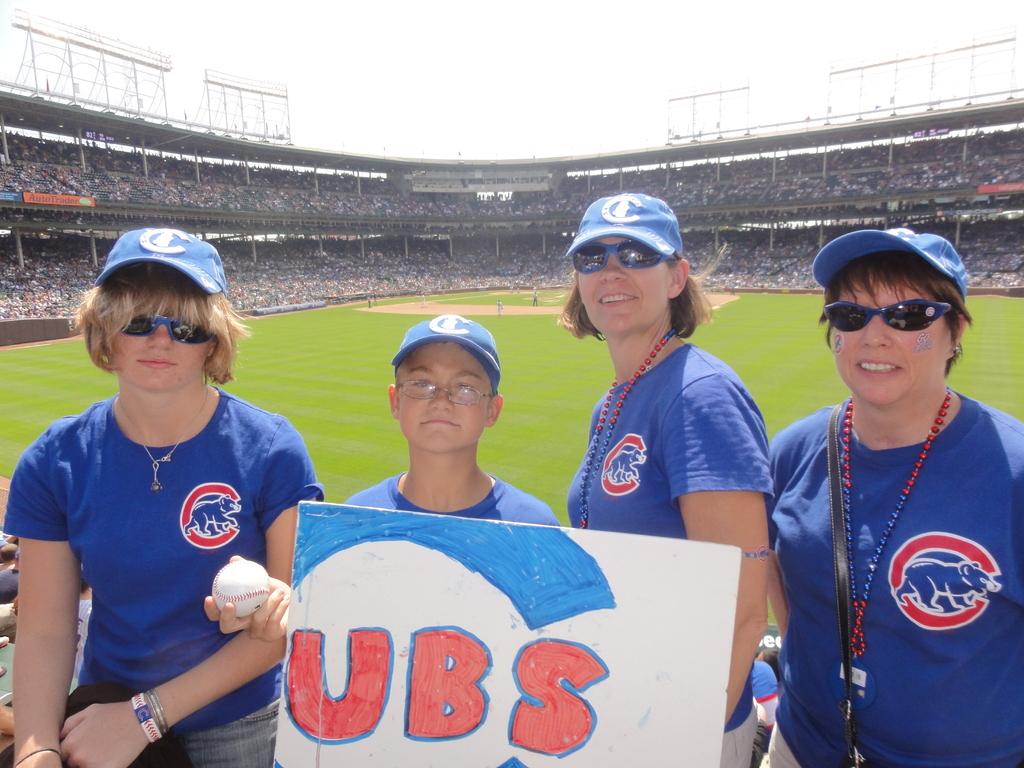What does it say on the white board they are holding?
Your answer should be very brief. Cubs. 